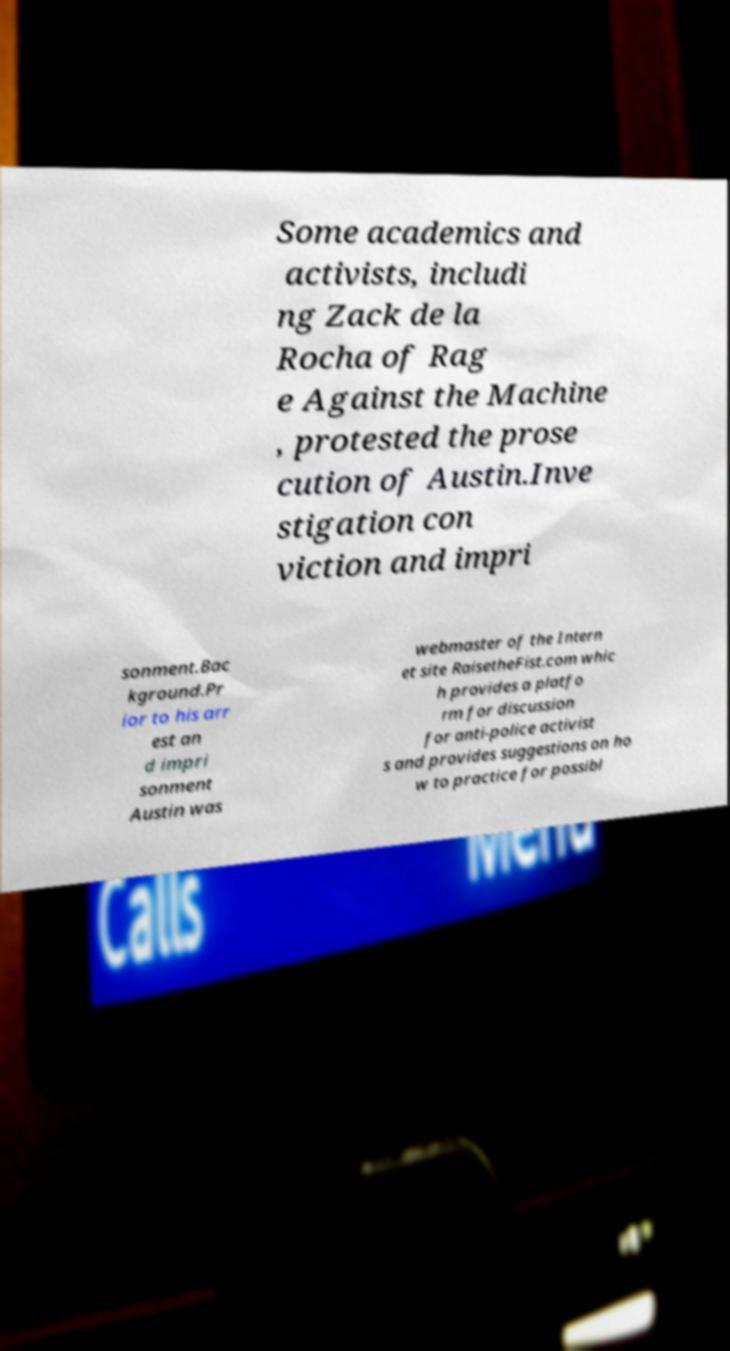Could you assist in decoding the text presented in this image and type it out clearly? Some academics and activists, includi ng Zack de la Rocha of Rag e Against the Machine , protested the prose cution of Austin.Inve stigation con viction and impri sonment.Bac kground.Pr ior to his arr est an d impri sonment Austin was webmaster of the Intern et site RaisetheFist.com whic h provides a platfo rm for discussion for anti-police activist s and provides suggestions on ho w to practice for possibl 